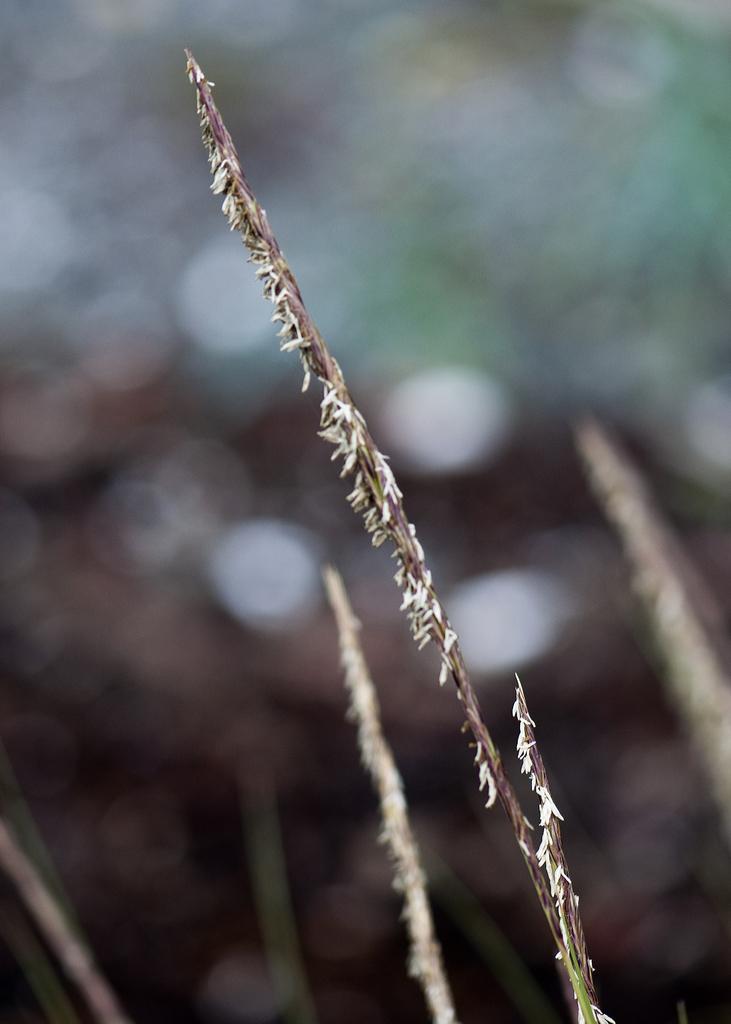Please provide a concise description of this image. In the picture I can see stem of a plant and the background image is blur. 